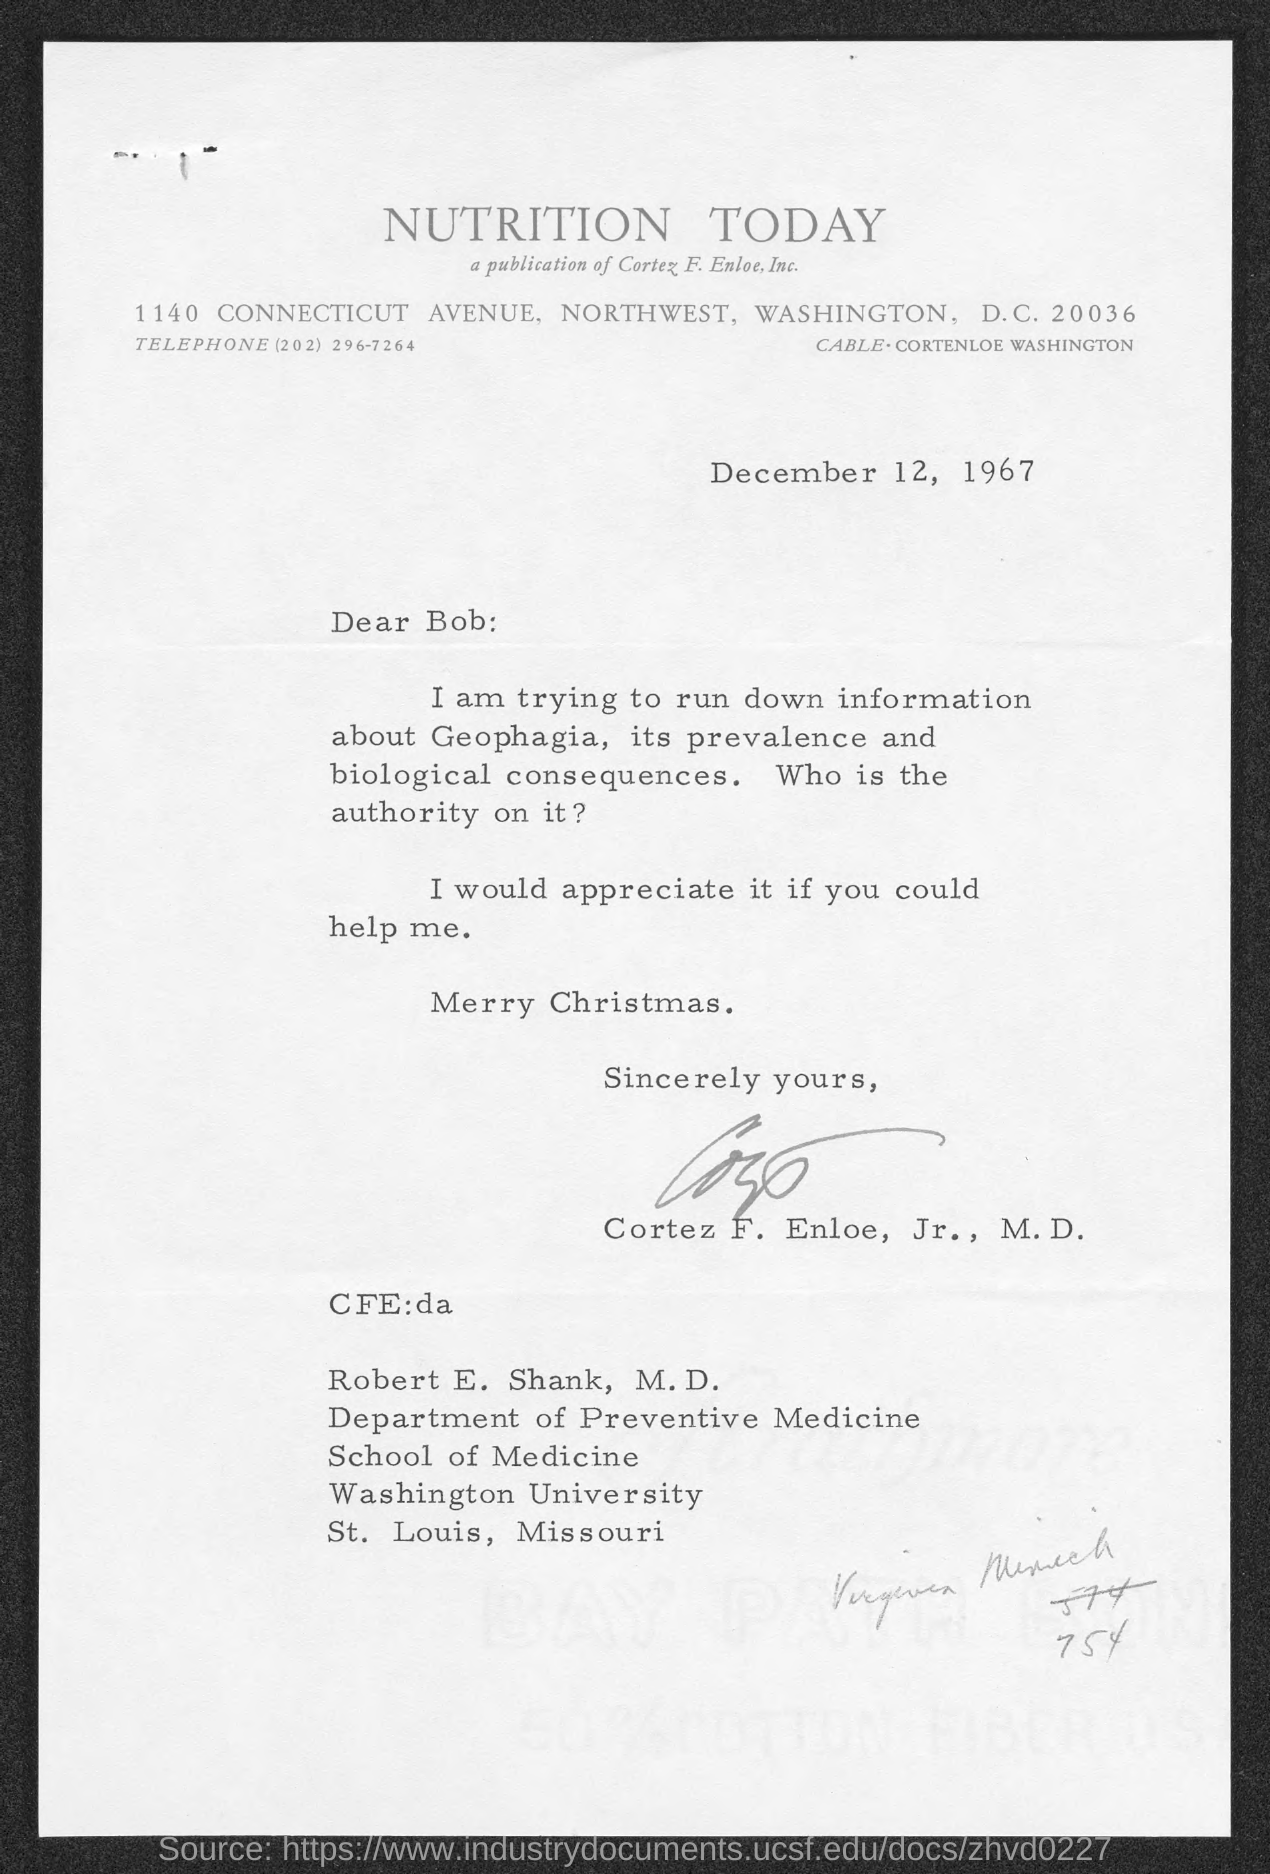What is the date?
Your answer should be compact. December 12, 1967. What is the salutation of this letter?
Give a very brief answer. Dear Bob:. 